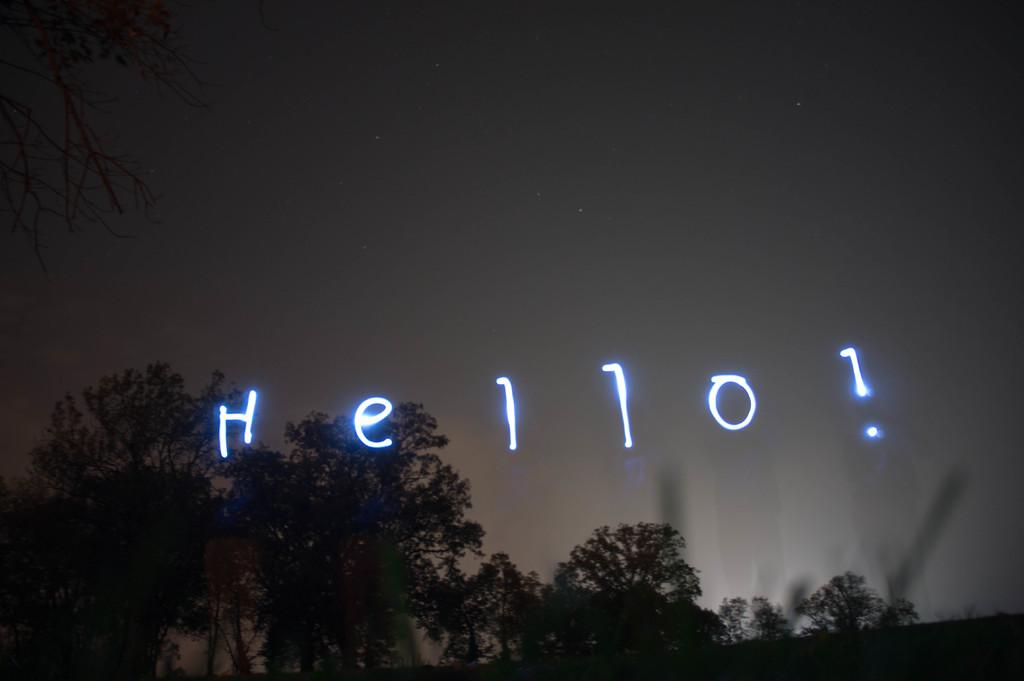What type of natural elements can be seen in the image? There are trees in the image. What else is present in the image besides the trees? There are letters with some effects in the image. What can be seen in the background of the image? The sky is visible in the background of the image. What is the size of the leaf on the tree in the image? There is no leaf visible in the image; it only shows trees in general. 